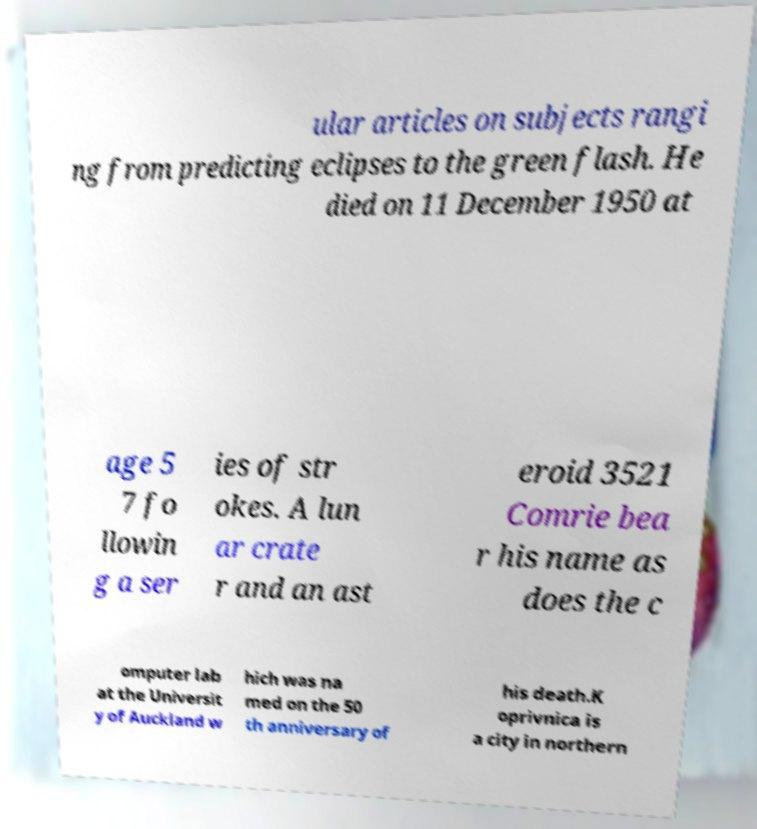For documentation purposes, I need the text within this image transcribed. Could you provide that? ular articles on subjects rangi ng from predicting eclipses to the green flash. He died on 11 December 1950 at age 5 7 fo llowin g a ser ies of str okes. A lun ar crate r and an ast eroid 3521 Comrie bea r his name as does the c omputer lab at the Universit y of Auckland w hich was na med on the 50 th anniversary of his death.K oprivnica is a city in northern 